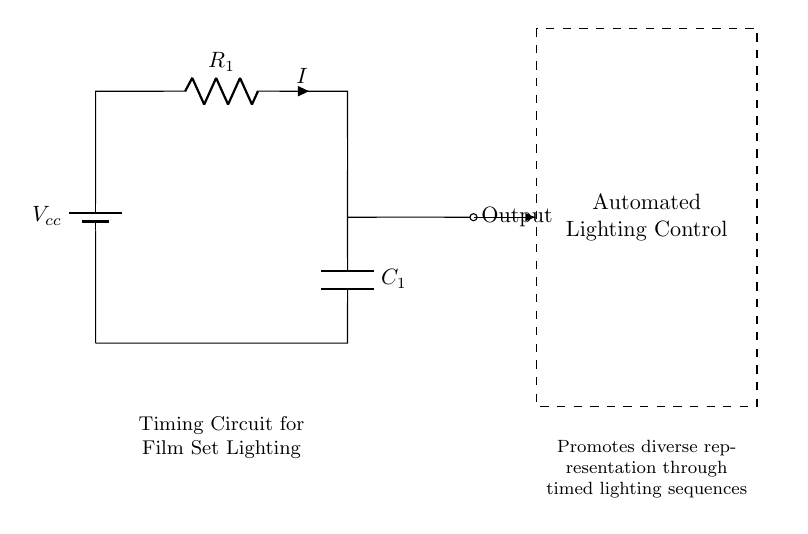What is the type of capacitor used in this circuit? The diagram indicates a capacitor labeled as C1. This is the only capacitor in the circuit, and it is a key component used to store charge and smooth the voltage output.
Answer: C1 What is the current flowing through the resistor? The current flowing through the resistor is labeled in the diagram as I. Since there are no additional values given in the circuit, we refer to the label directly.
Answer: I Which component is used for timing in this circuit? The timing function in this circuit is provided by the capacitor, which charges and discharges over time, thus controlling the timing for automated lighting.
Answer: Capacitor What is the role of the resistor in this circuit? The resistor is used to limit the current flowing into the capacitor, controlling the rate at which the capacitor charges and discharges. This defines the timing characteristics of the circuit.
Answer: Limit current What happens to the output when the capacitor is fully charged? When the capacitor is fully charged, the output voltage stabilizes, and the current ceases to flow, resulting in a constant output until the capacitor discharges. This behavior is essential for creating timed light control sequences.
Answer: Output stabilizes What is the significance of the dashed rectangle in the circuit? The dashed rectangle signifies the area designated for automated lighting control, indicating that this circuit influences or interacts with lighting equipment on set through timed sequences.
Answer: Automated lighting control 